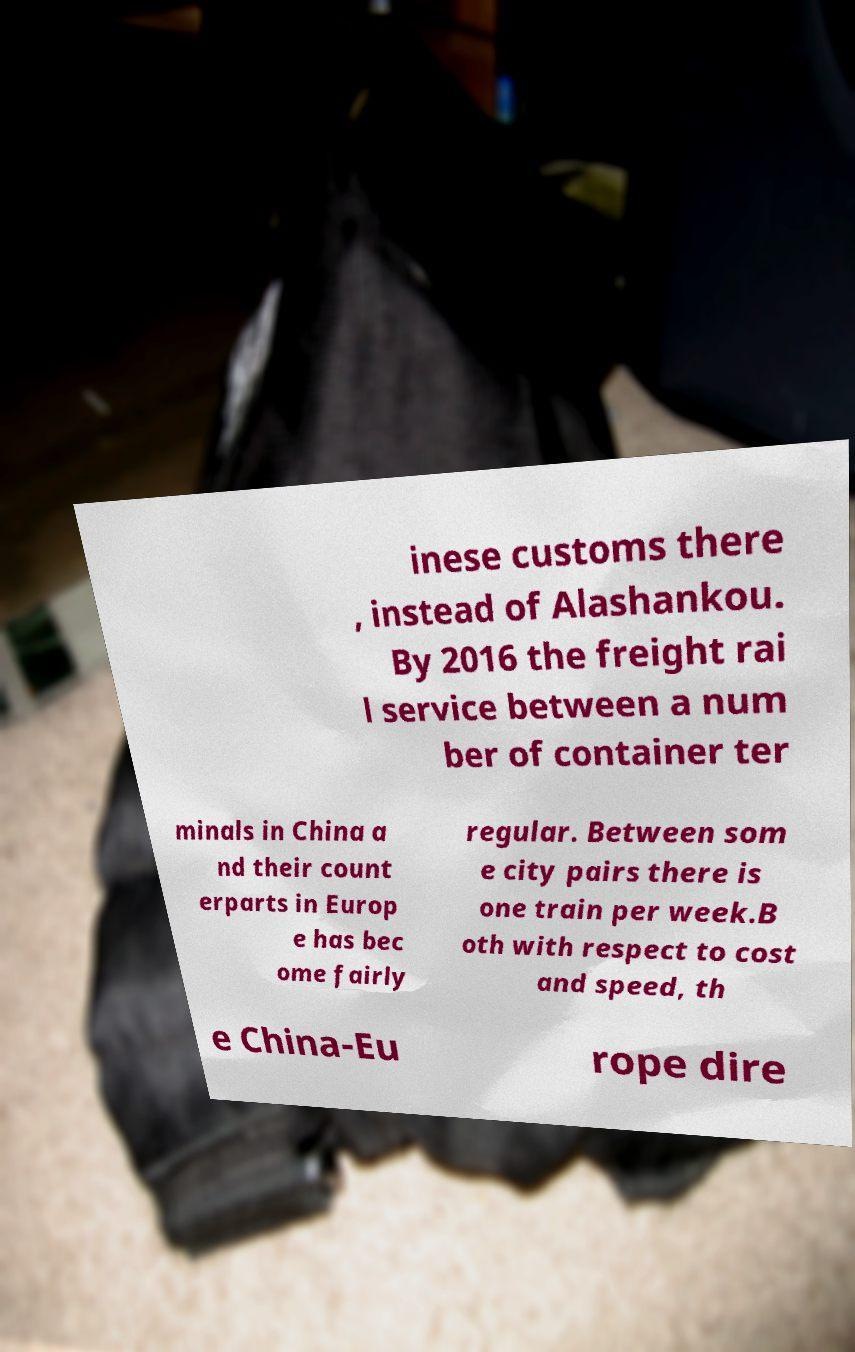I need the written content from this picture converted into text. Can you do that? inese customs there , instead of Alashankou. By 2016 the freight rai l service between a num ber of container ter minals in China a nd their count erparts in Europ e has bec ome fairly regular. Between som e city pairs there is one train per week.B oth with respect to cost and speed, th e China-Eu rope dire 